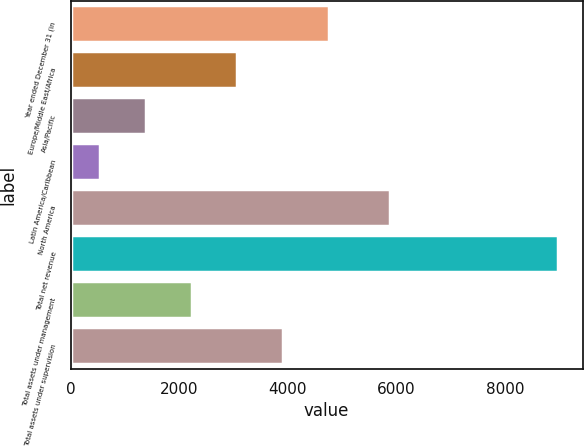<chart> <loc_0><loc_0><loc_500><loc_500><bar_chart><fcel>Year ended December 31 (in<fcel>Europe/Middle East/Africa<fcel>Asia/Pacific<fcel>Latin America/Caribbean<fcel>North America<fcel>Total net revenue<fcel>Total assets under management<fcel>Total assets under supervision<nl><fcel>4762.5<fcel>3073.9<fcel>1385.3<fcel>541<fcel>5876<fcel>8984<fcel>2229.6<fcel>3918.2<nl></chart> 